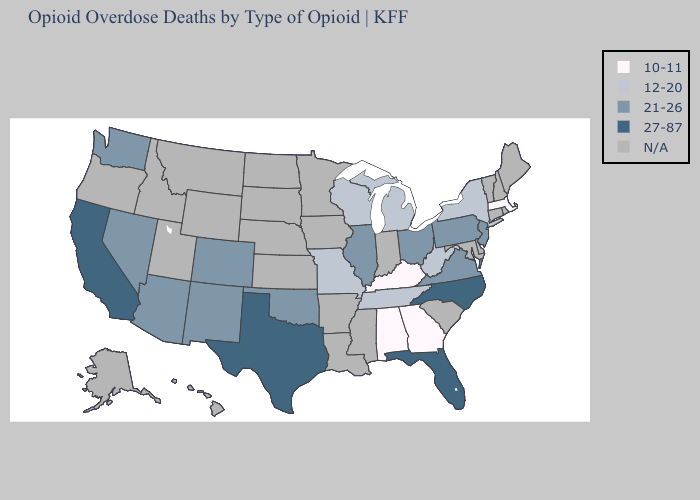Name the states that have a value in the range 27-87?
Quick response, please. California, Florida, North Carolina, Texas. Among the states that border Mississippi , which have the lowest value?
Quick response, please. Alabama. Among the states that border Minnesota , which have the highest value?
Concise answer only. Wisconsin. What is the highest value in the USA?
Short answer required. 27-87. Name the states that have a value in the range 10-11?
Short answer required. Alabama, Georgia, Kentucky, Massachusetts. What is the lowest value in the USA?
Quick response, please. 10-11. Does the first symbol in the legend represent the smallest category?
Give a very brief answer. Yes. Does Arizona have the lowest value in the West?
Write a very short answer. Yes. Among the states that border New Jersey , which have the highest value?
Give a very brief answer. Pennsylvania. What is the value of New Mexico?
Give a very brief answer. 21-26. Which states have the highest value in the USA?
Keep it brief. California, Florida, North Carolina, Texas. How many symbols are there in the legend?
Answer briefly. 5. What is the lowest value in the South?
Be succinct. 10-11. 